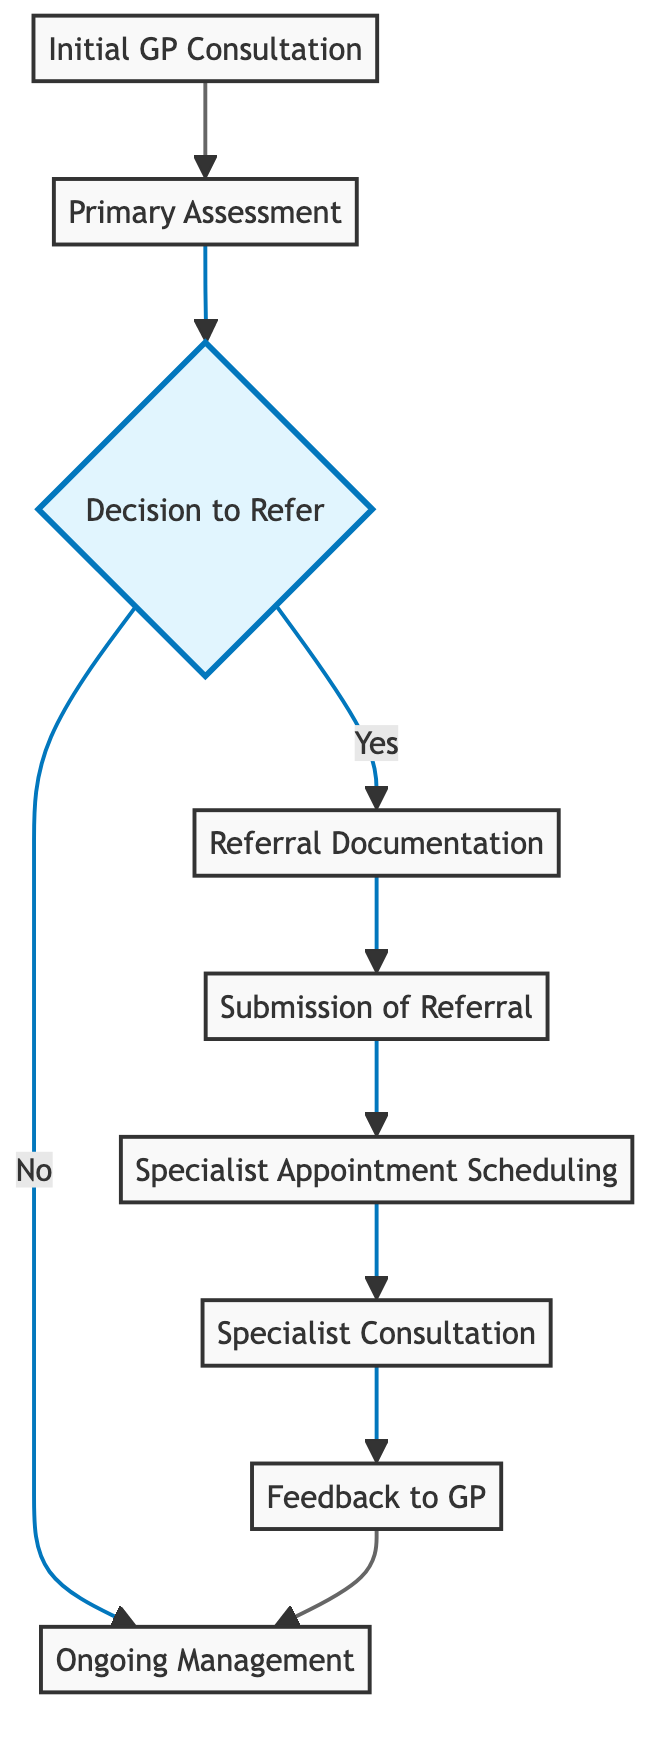What is the first step in the referral process? The first step in the referral process is the “Initial GP Consultation,” where the patient visits their GP for an assessment.
Answer: Initial GP Consultation How many steps are there in the referral process? Counting all the nodes in the diagram, there are a total of 9 steps outlined in the referral process.
Answer: 9 What comes after "Submission of Referral"? After the "Submission of Referral," the next step is "Specialist Appointment Scheduling," which involves the specialist's office reviewing the referral.
Answer: Specialist Appointment Scheduling What decision point exists in the referral process? The decision point in the process is labeled as “Decision to Refer,” where the GP decides whether to refer the patient to a specialist or continue with ongoing management.
Answer: Decision to Refer What happens if the GP decides not to refer the patient? If the GP decides not to refer the patient, the process moves directly to "Ongoing Management," indicating that care continues without specialist input.
Answer: Ongoing Management What type of feedback does the specialist provide? The specialist provides "Feedback to GP," which includes updates on diagnosis, treatment plan, and ongoing management after the consultation.
Answer: Feedback to GP What is required before the "Submission of Referral"? Before "Submission of Referral," the "Referral Documentation" must be completed, detailing the patient's condition and reasons for referral.
Answer: Referral Documentation What is the nature of the relationship between "Specialist Consultation" and "Feedback to GP"? The relationship between "Specialist Consultation" and "Feedback to GP" is sequential, as feedback is provided after the specialist appointment to update the GP.
Answer: Sequential What does the flowchart specifically represent? The flowchart represents the "Referral Process from Local GP to Specialist," outlining each step involved in the pathway.
Answer: Referral Process from Local GP to Specialist 